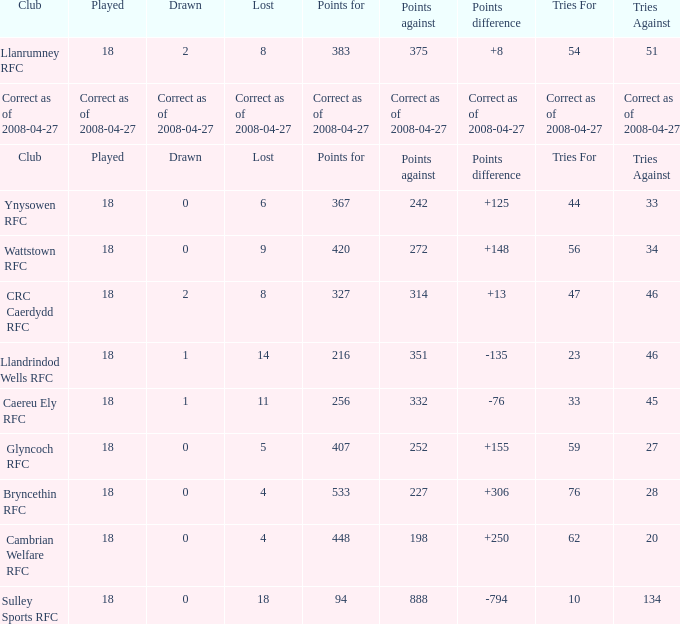What is the value for the item "Tries" when the value of the item "Played" is 18 and the value of the item "Points" is 375? 54.0. 